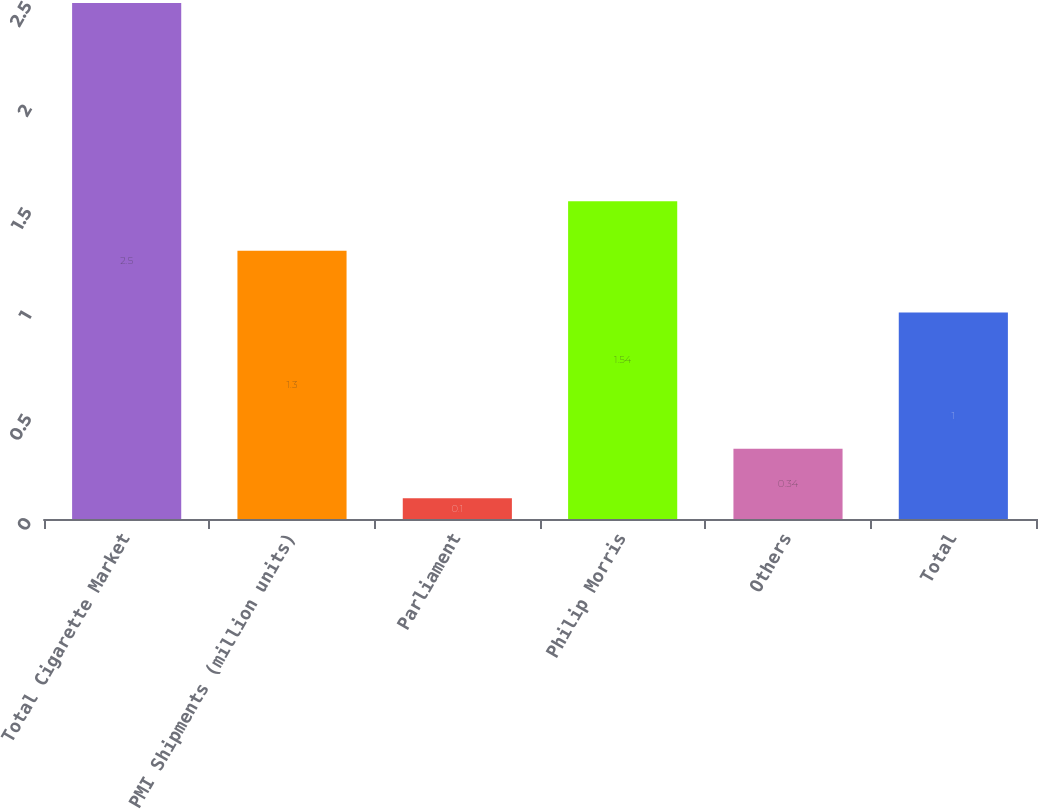Convert chart to OTSL. <chart><loc_0><loc_0><loc_500><loc_500><bar_chart><fcel>Total Cigarette Market<fcel>PMI Shipments (million units)<fcel>Parliament<fcel>Philip Morris<fcel>Others<fcel>Total<nl><fcel>2.5<fcel>1.3<fcel>0.1<fcel>1.54<fcel>0.34<fcel>1<nl></chart> 